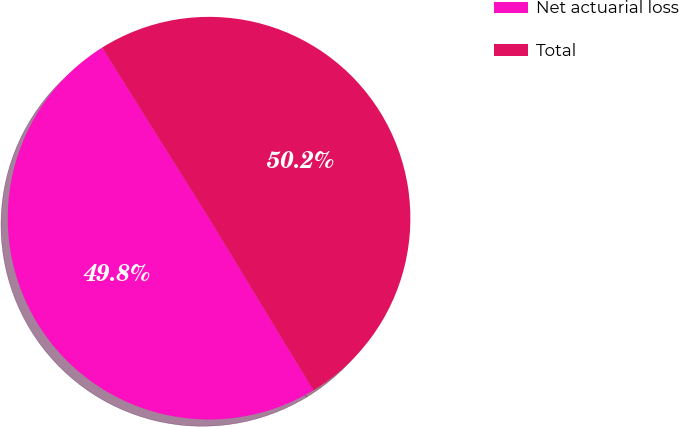Convert chart. <chart><loc_0><loc_0><loc_500><loc_500><pie_chart><fcel>Net actuarial loss<fcel>Total<nl><fcel>49.77%<fcel>50.23%<nl></chart> 